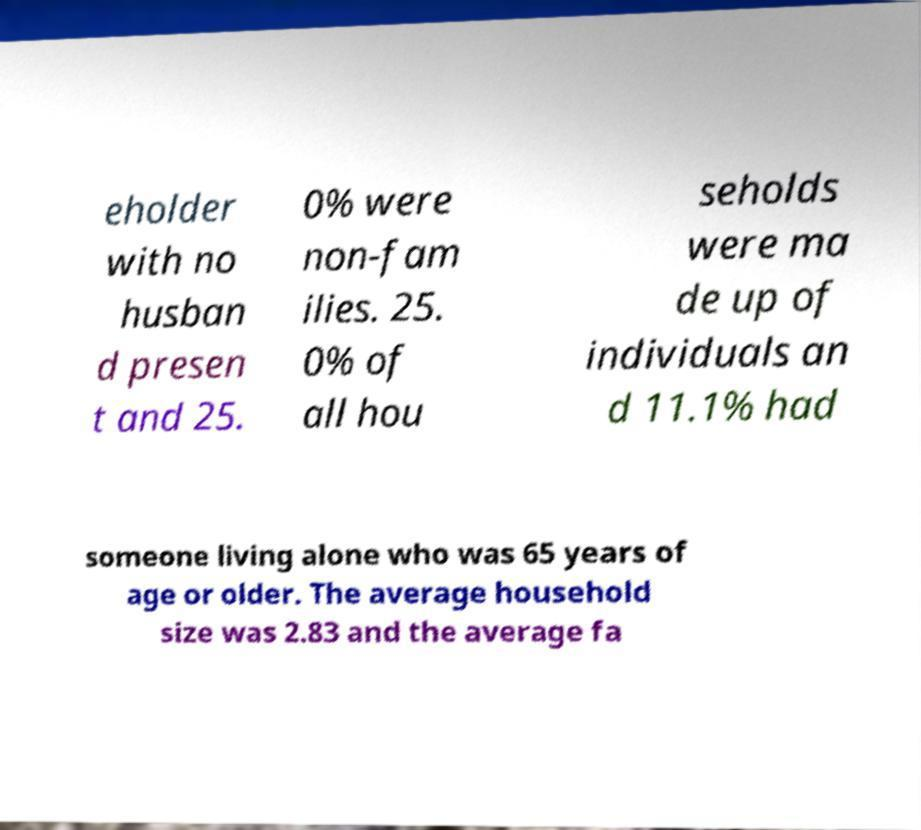Can you read and provide the text displayed in the image?This photo seems to have some interesting text. Can you extract and type it out for me? eholder with no husban d presen t and 25. 0% were non-fam ilies. 25. 0% of all hou seholds were ma de up of individuals an d 11.1% had someone living alone who was 65 years of age or older. The average household size was 2.83 and the average fa 